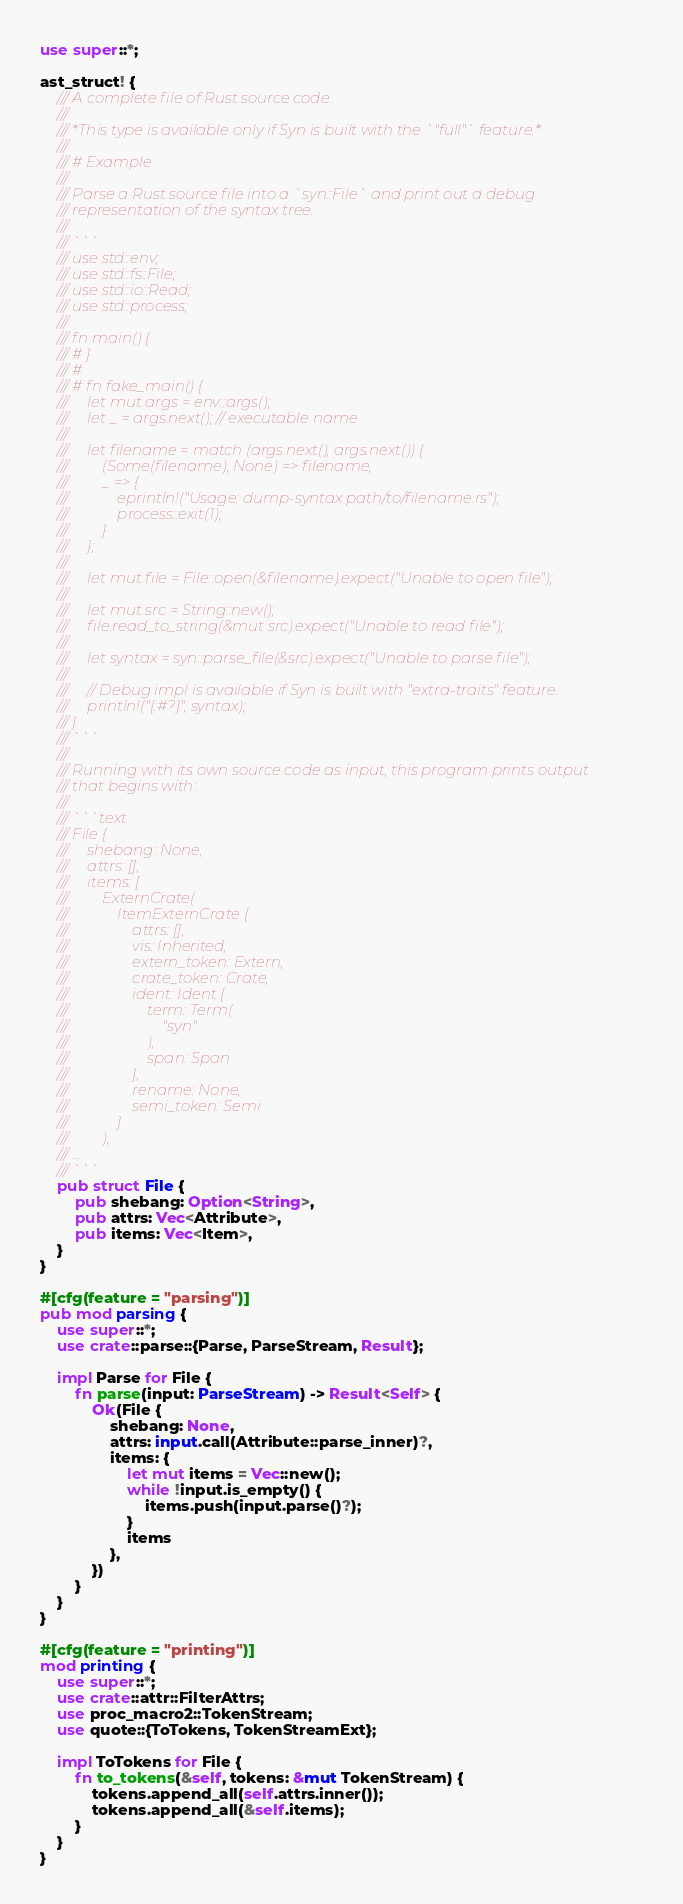<code> <loc_0><loc_0><loc_500><loc_500><_Rust_>use super::*;

ast_struct! {
    /// A complete file of Rust source code.
    ///
    /// *This type is available only if Syn is built with the `"full"` feature.*
    ///
    /// # Example
    ///
    /// Parse a Rust source file into a `syn::File` and print out a debug
    /// representation of the syntax tree.
    ///
    /// ```
    /// use std::env;
    /// use std::fs::File;
    /// use std::io::Read;
    /// use std::process;
    ///
    /// fn main() {
    /// # }
    /// #
    /// # fn fake_main() {
    ///     let mut args = env::args();
    ///     let _ = args.next(); // executable name
    ///
    ///     let filename = match (args.next(), args.next()) {
    ///         (Some(filename), None) => filename,
    ///         _ => {
    ///             eprintln!("Usage: dump-syntax path/to/filename.rs");
    ///             process::exit(1);
    ///         }
    ///     };
    ///
    ///     let mut file = File::open(&filename).expect("Unable to open file");
    ///
    ///     let mut src = String::new();
    ///     file.read_to_string(&mut src).expect("Unable to read file");
    ///
    ///     let syntax = syn::parse_file(&src).expect("Unable to parse file");
    ///
    ///     // Debug impl is available if Syn is built with "extra-traits" feature.
    ///     println!("{:#?}", syntax);
    /// }
    /// ```
    ///
    /// Running with its own source code as input, this program prints output
    /// that begins with:
    ///
    /// ```text
    /// File {
    ///     shebang: None,
    ///     attrs: [],
    ///     items: [
    ///         ExternCrate(
    ///             ItemExternCrate {
    ///                 attrs: [],
    ///                 vis: Inherited,
    ///                 extern_token: Extern,
    ///                 crate_token: Crate,
    ///                 ident: Ident {
    ///                     term: Term(
    ///                         "syn"
    ///                     ),
    ///                     span: Span
    ///                 },
    ///                 rename: None,
    ///                 semi_token: Semi
    ///             }
    ///         ),
    /// ...
    /// ```
    pub struct File {
        pub shebang: Option<String>,
        pub attrs: Vec<Attribute>,
        pub items: Vec<Item>,
    }
}

#[cfg(feature = "parsing")]
pub mod parsing {
    use super::*;
    use crate::parse::{Parse, ParseStream, Result};

    impl Parse for File {
        fn parse(input: ParseStream) -> Result<Self> {
            Ok(File {
                shebang: None,
                attrs: input.call(Attribute::parse_inner)?,
                items: {
                    let mut items = Vec::new();
                    while !input.is_empty() {
                        items.push(input.parse()?);
                    }
                    items
                },
            })
        }
    }
}

#[cfg(feature = "printing")]
mod printing {
    use super::*;
    use crate::attr::FilterAttrs;
    use proc_macro2::TokenStream;
    use quote::{ToTokens, TokenStreamExt};

    impl ToTokens for File {
        fn to_tokens(&self, tokens: &mut TokenStream) {
            tokens.append_all(self.attrs.inner());
            tokens.append_all(&self.items);
        }
    }
}
</code> 